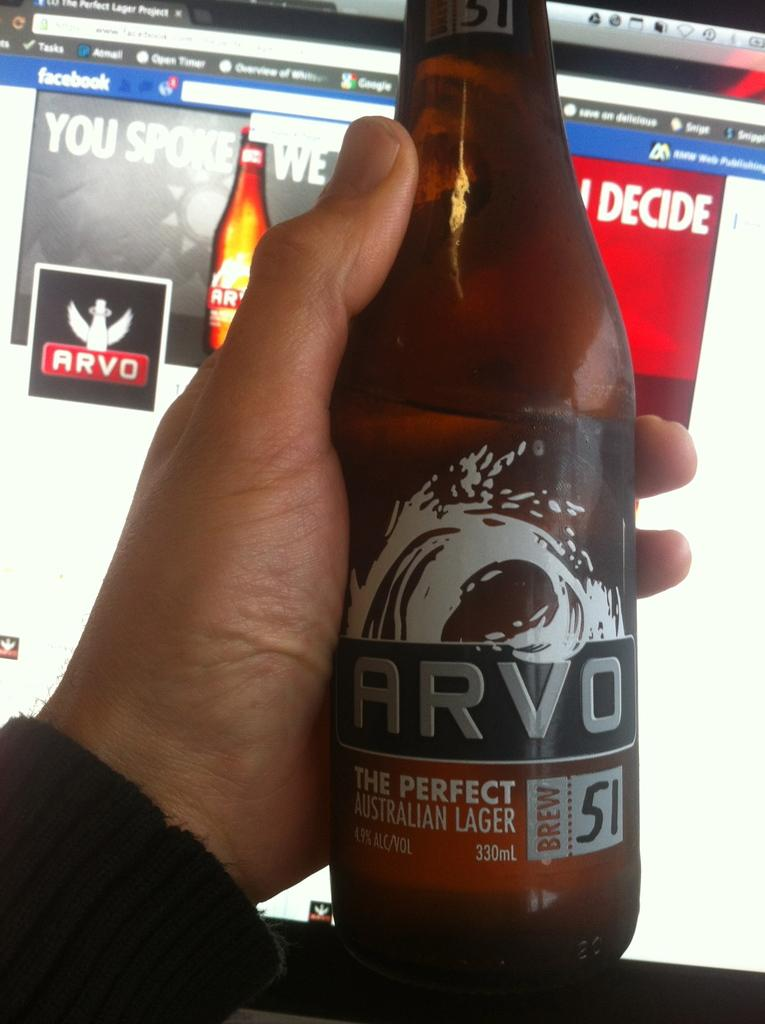<image>
Describe the image concisely. a bottle of arvo the perfect australian lager 